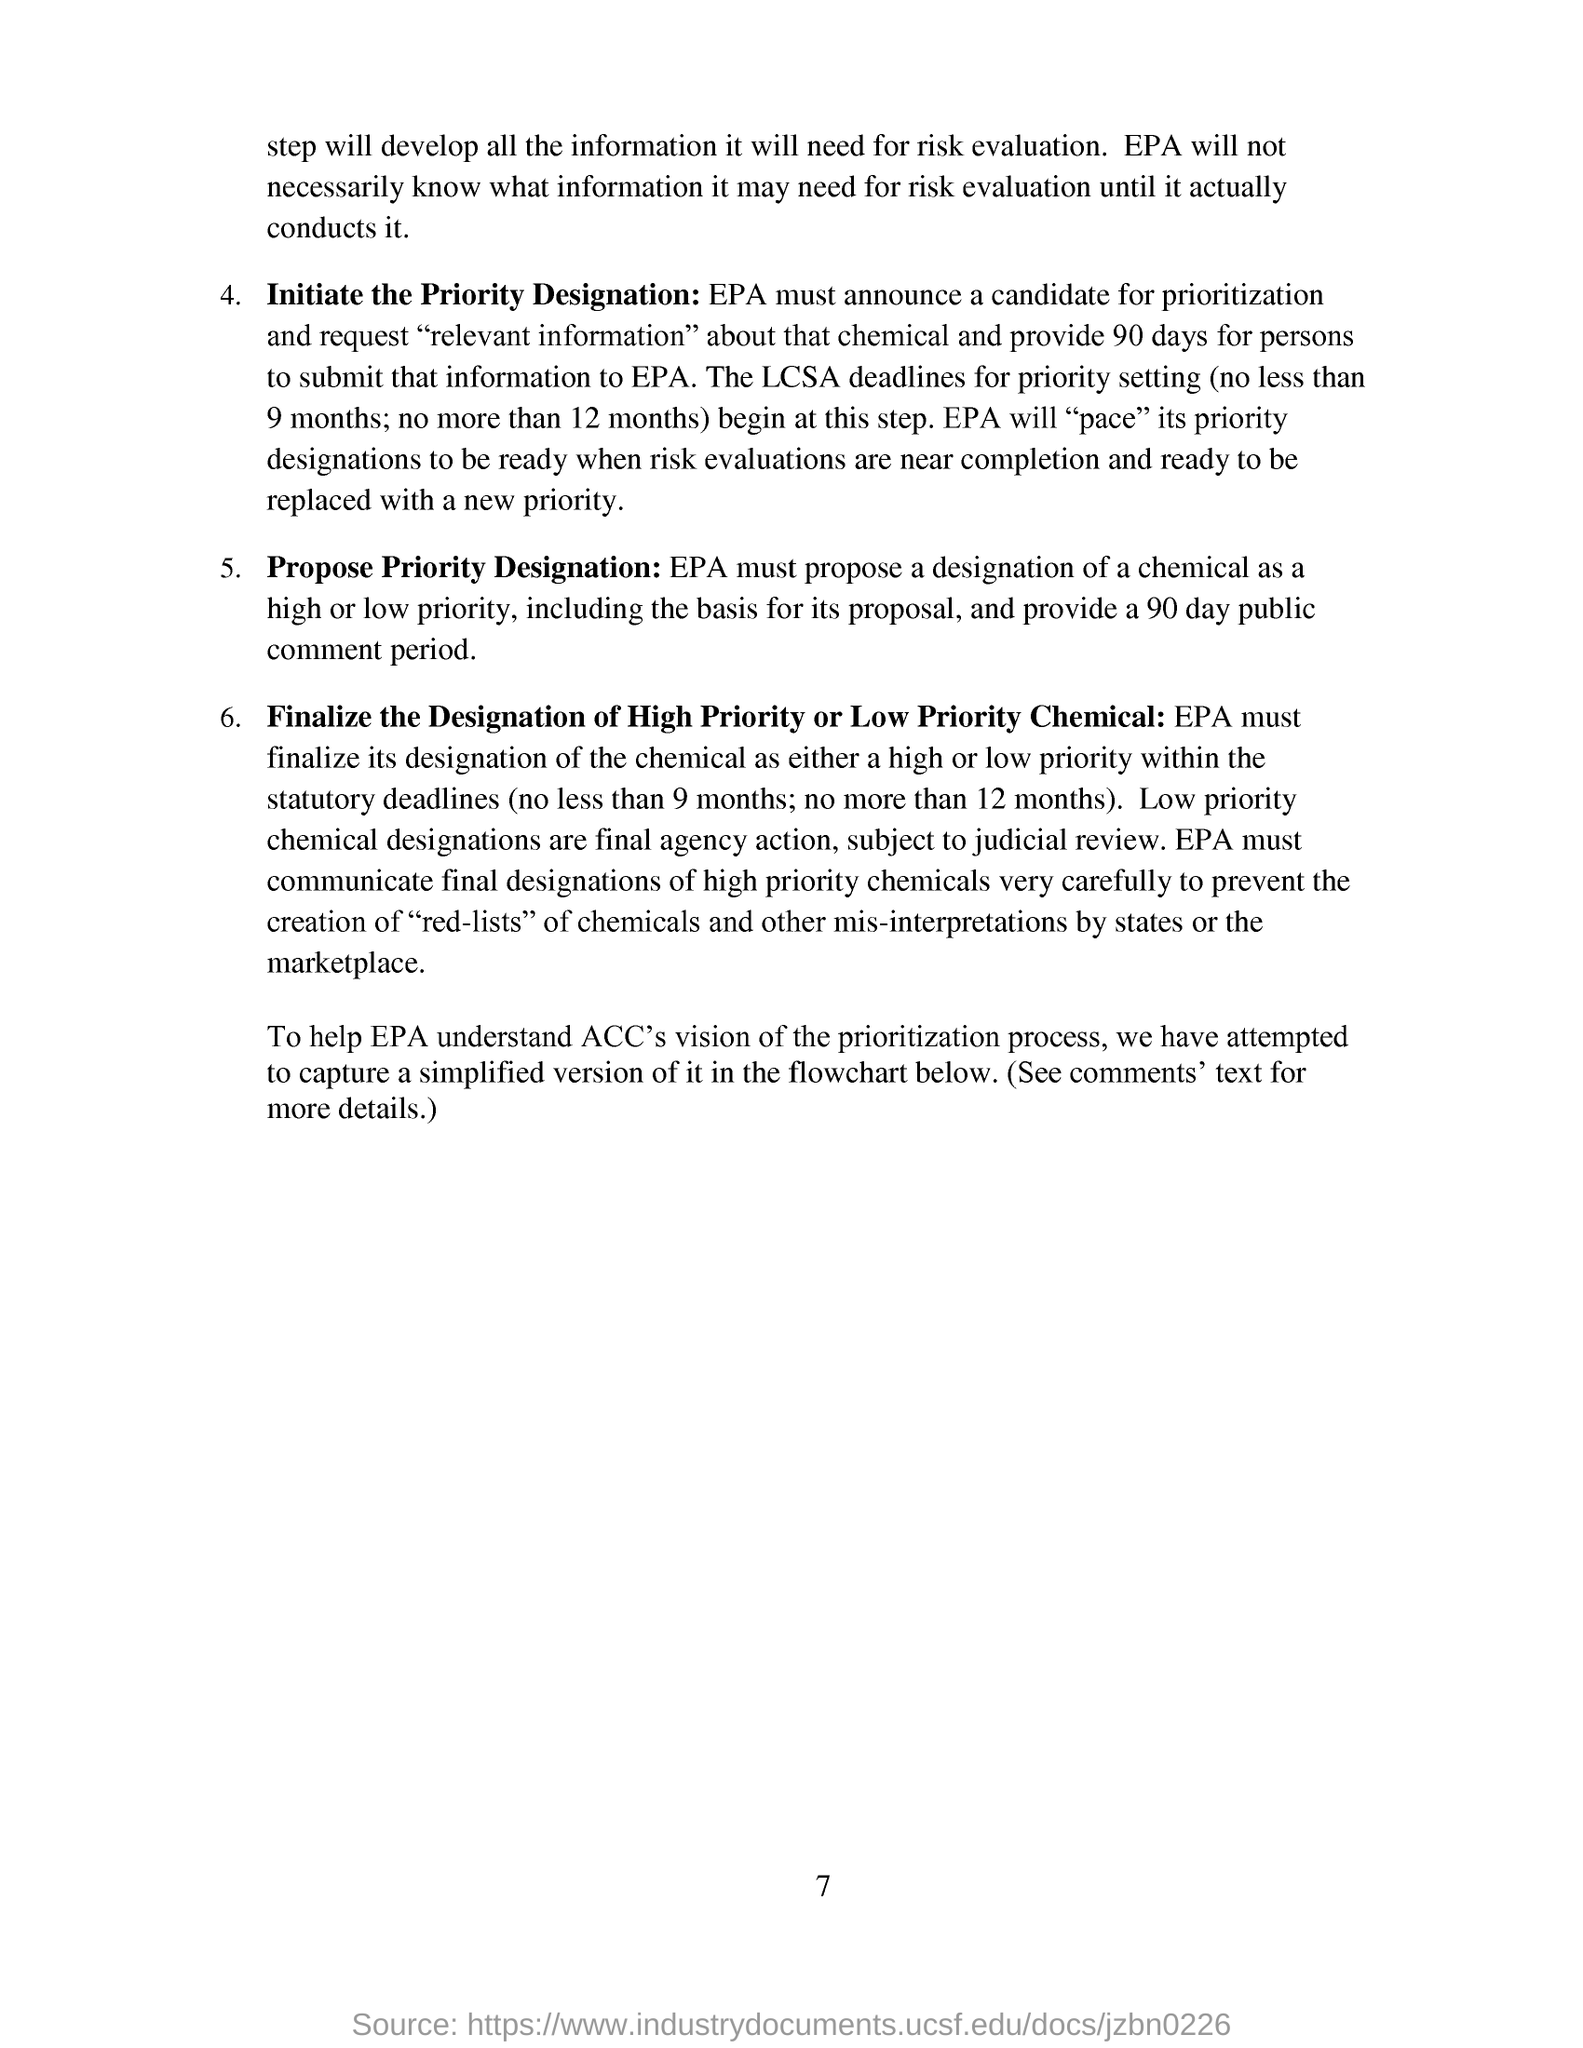Give some essential details in this illustration. The Environmental Protection Agency (EPA) is responsible for determining the designation of a chemical as a high or low priority. The public comment period is 90 days long. The Environmental Protection Agency is responsible for initiating the process of designating a priority for a contaminant under the Comprehensive Environmental Response, Compensation, and Liability Act. The people have been granted 90 days to submit relevant information about that chemical. 